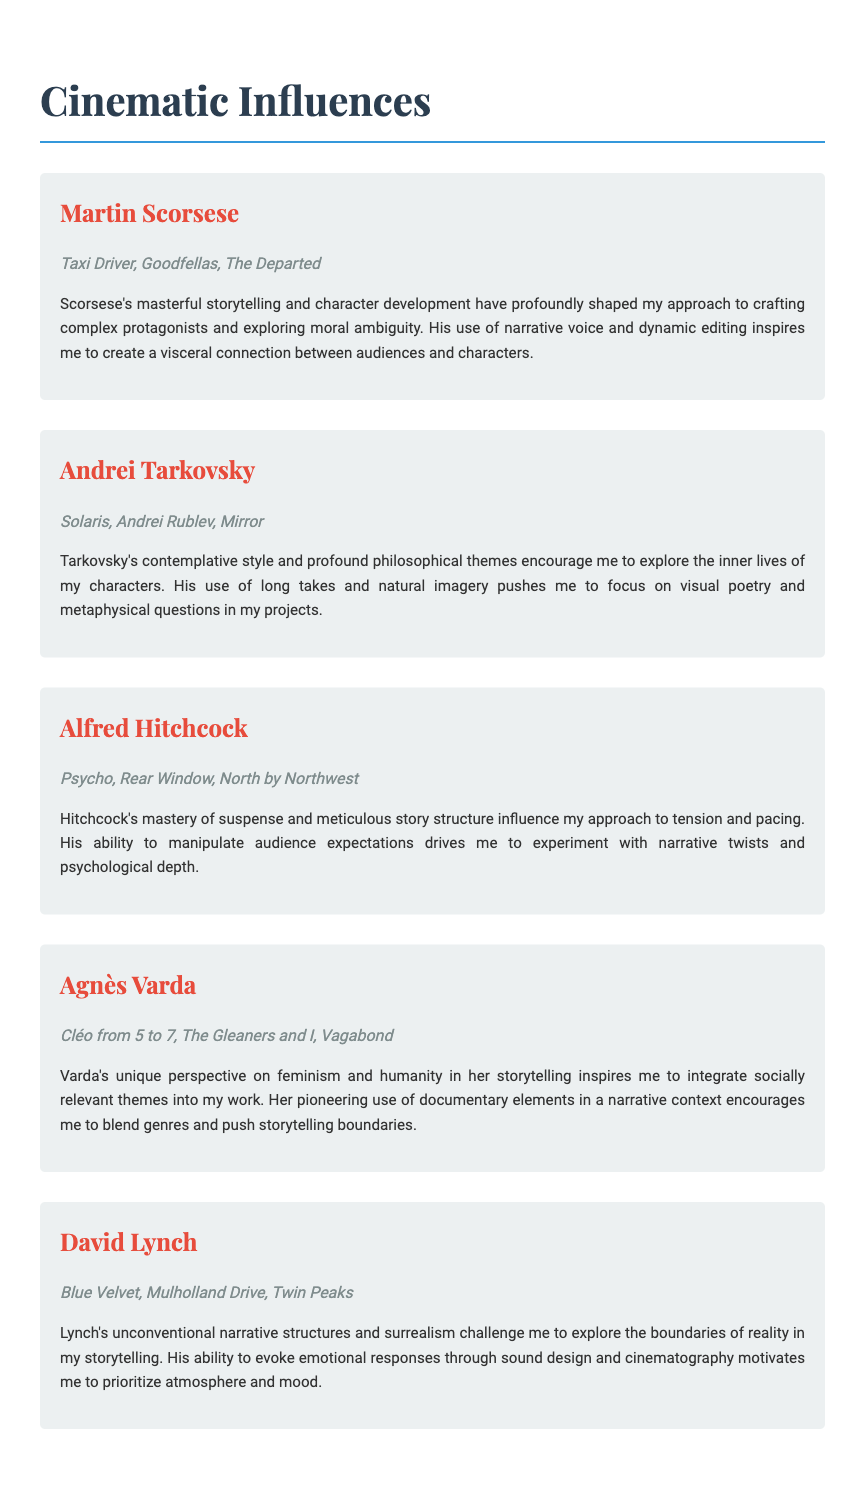What is the title of the document? The title of the document, which appears prominently at the top, is "Cinematic Influences".
Answer: Cinematic Influences How many filmmakers are listed in the document? The document lists five influential filmmakers in total.
Answer: 5 Which film by Martin Scorsese is mentioned? Among the films mentioned for Martin Scorsese, "Taxi Driver" is one of them.
Answer: Taxi Driver What theme does Agnès Varda integrate into her storytelling? The document notes that Varda integrates socially relevant themes into her work.
Answer: Socially relevant themes What narrative element does David Lynch prioritize in his storytelling? Lynch is noted for prioritizing atmosphere and mood in his storytelling.
Answer: Atmosphere and mood Which filmmaker is associated with the film "Mulholland Drive"? The filmmaker associated with "Mulholland Drive" is David Lynch.
Answer: David Lynch What influence does Alfred Hitchcock have on the approach to tension? Hitchcock's mastery of suspense influences the approach to tension in storytelling.
Answer: Suspense What cinematic technique is Andrei Tarkovsky known for? Tarkovsky is known for his use of long takes in his films.
Answer: Long takes 